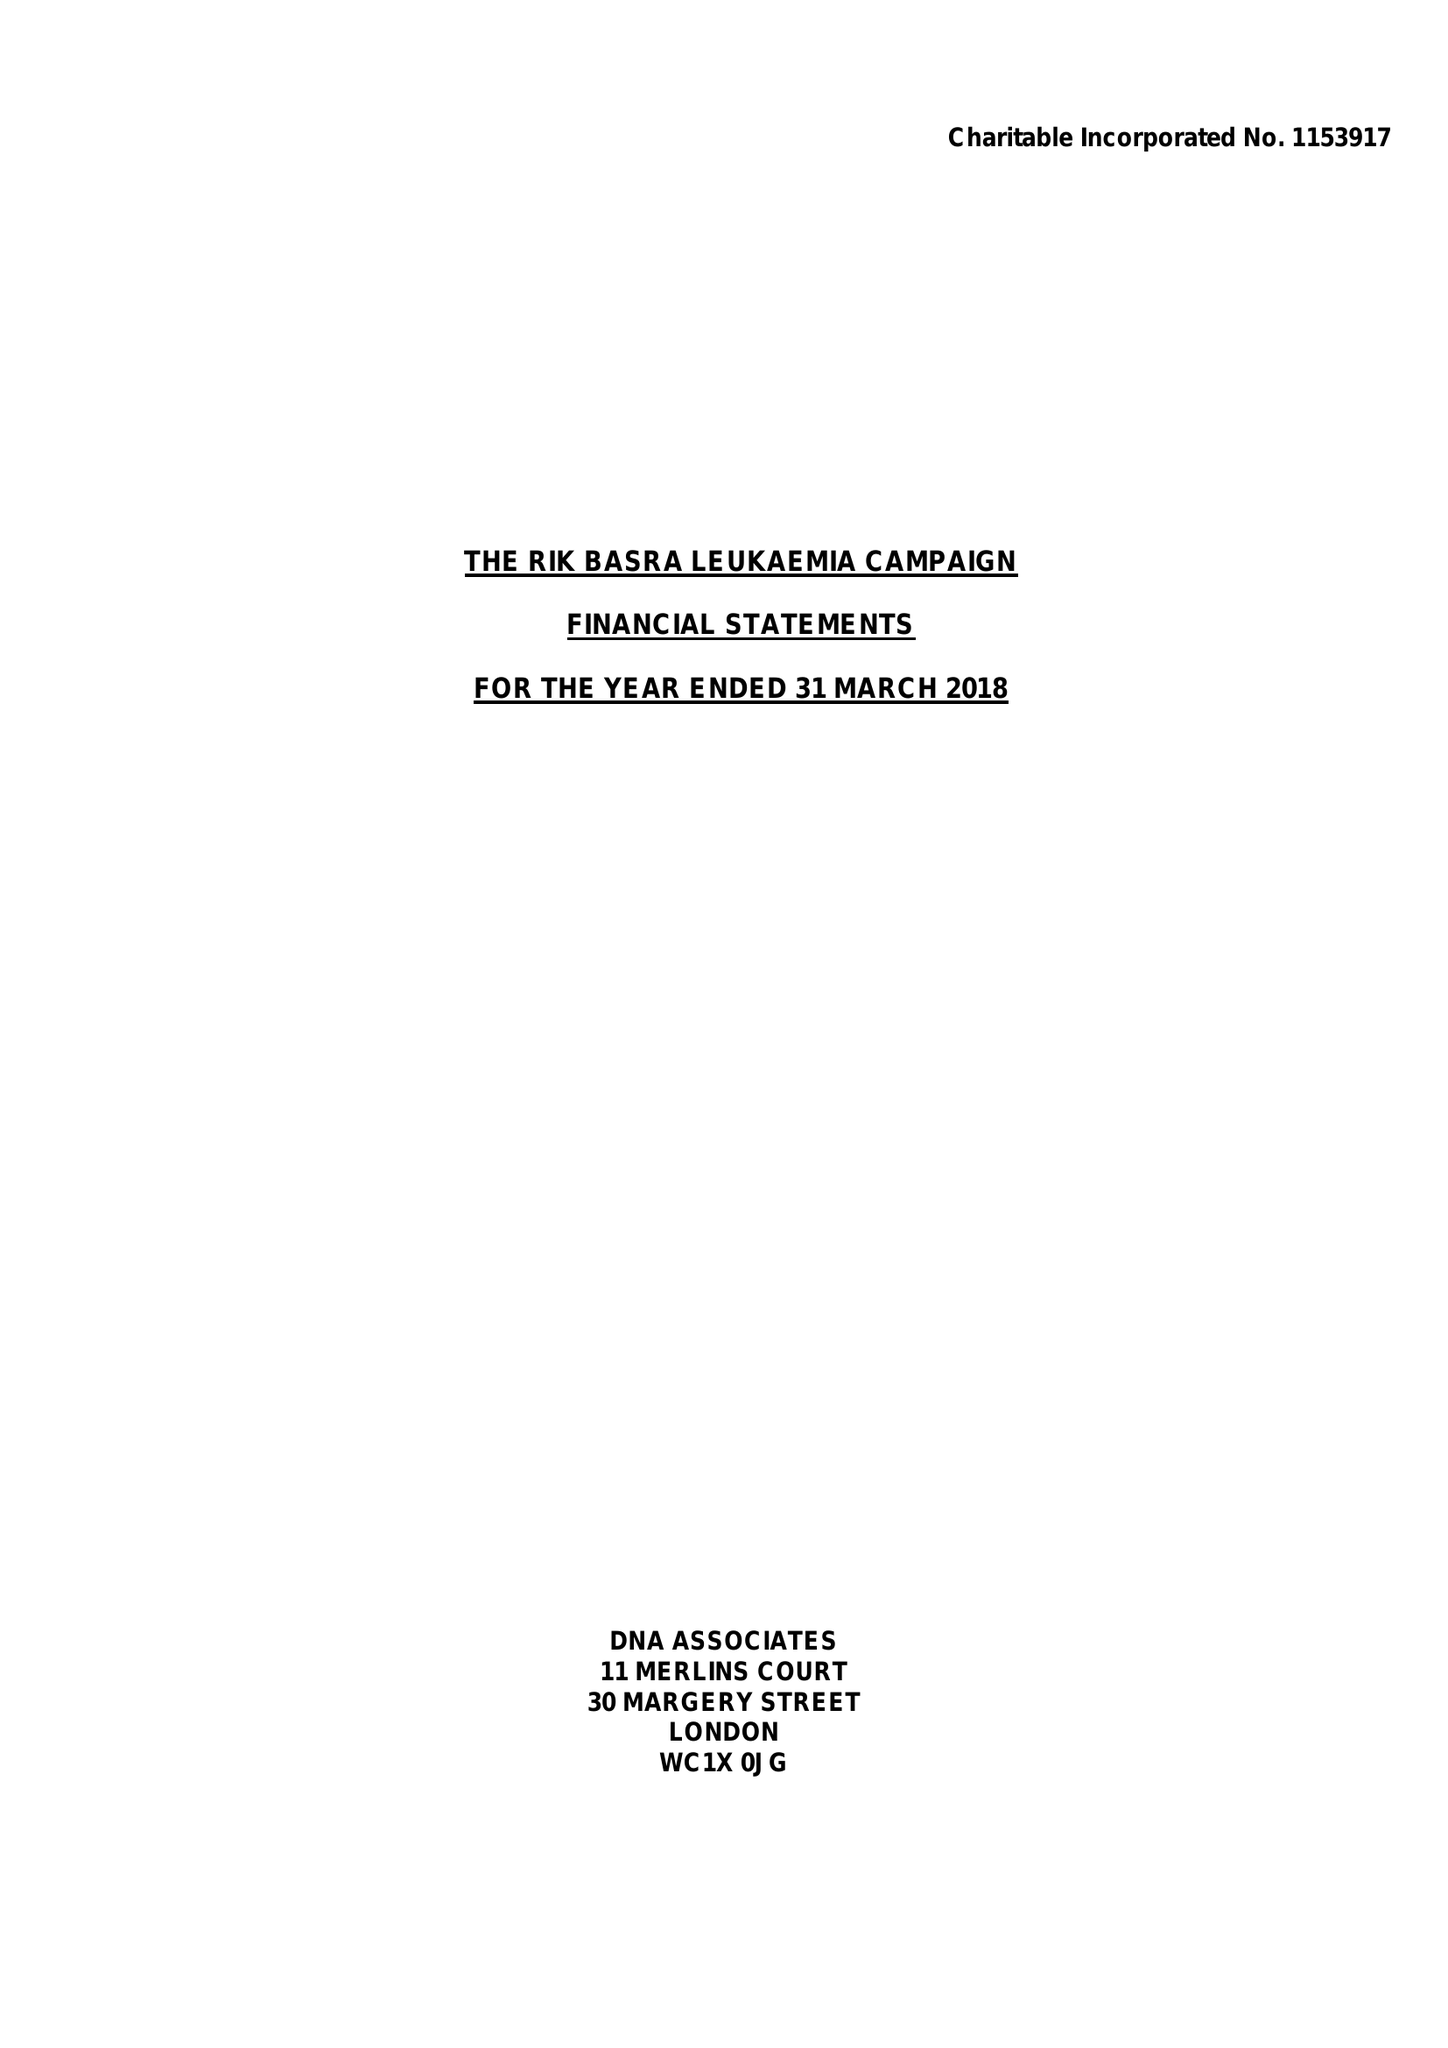What is the value for the address__street_line?
Answer the question using a single word or phrase. 2 ROCHESTER CLOSE 